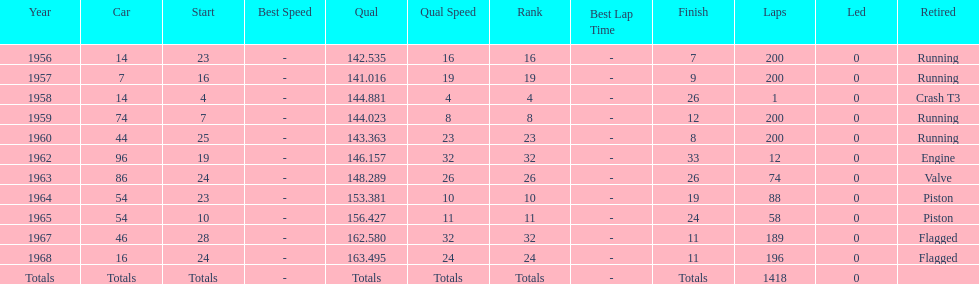Which year is the last qual on the chart 1968. 